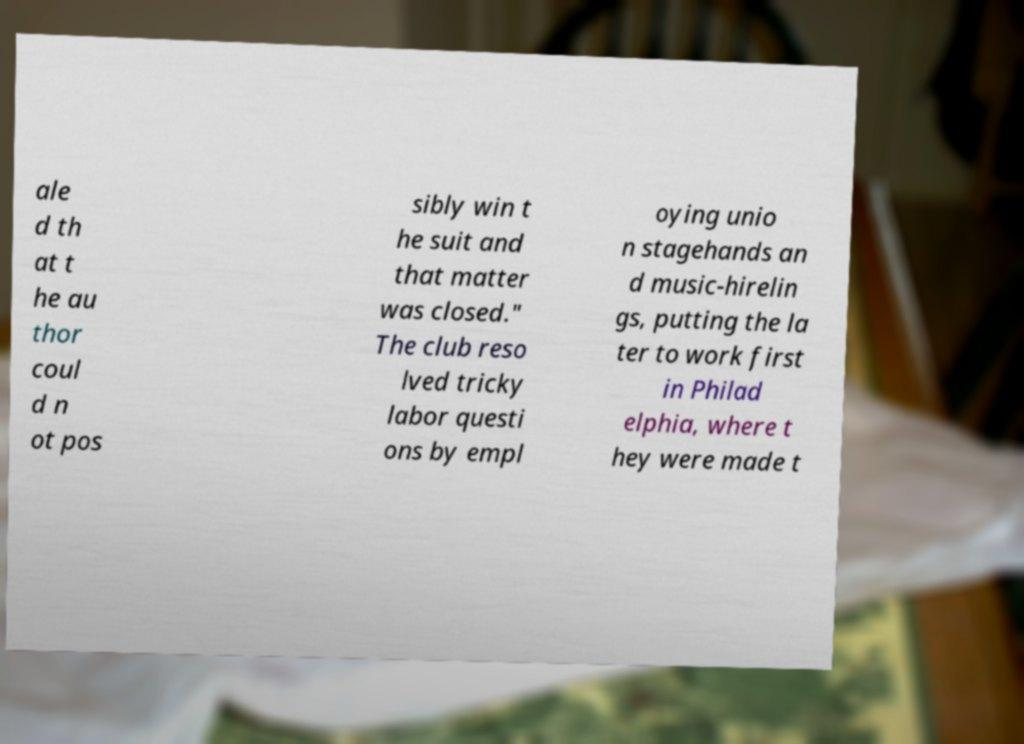There's text embedded in this image that I need extracted. Can you transcribe it verbatim? ale d th at t he au thor coul d n ot pos sibly win t he suit and that matter was closed." The club reso lved tricky labor questi ons by empl oying unio n stagehands an d music-hirelin gs, putting the la ter to work first in Philad elphia, where t hey were made t 